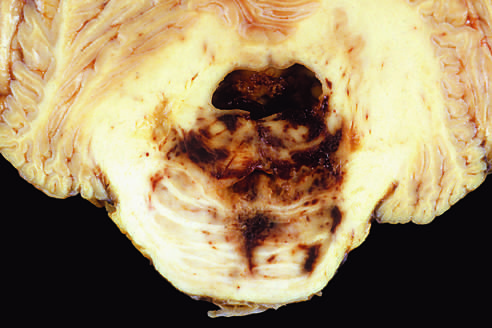what leads to hemorrhage?
Answer the question using a single word or phrase. Disruption of the vessels that enter the pons along the midline 